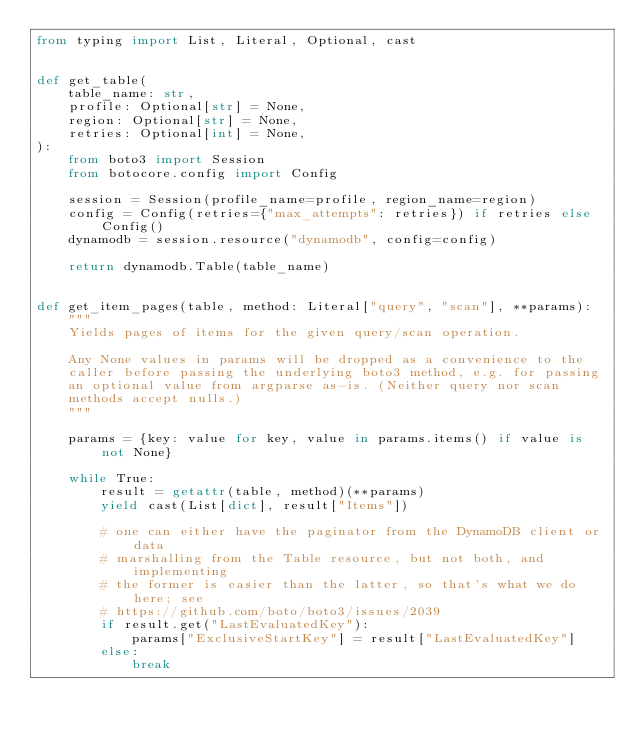<code> <loc_0><loc_0><loc_500><loc_500><_Python_>from typing import List, Literal, Optional, cast


def get_table(
    table_name: str,
    profile: Optional[str] = None,
    region: Optional[str] = None,
    retries: Optional[int] = None,
):
    from boto3 import Session
    from botocore.config import Config

    session = Session(profile_name=profile, region_name=region)
    config = Config(retries={"max_attempts": retries}) if retries else Config()
    dynamodb = session.resource("dynamodb", config=config)

    return dynamodb.Table(table_name)


def get_item_pages(table, method: Literal["query", "scan"], **params):
    """
    Yields pages of items for the given query/scan operation.

    Any None values in params will be dropped as a convenience to the
    caller before passing the underlying boto3 method, e.g. for passing
    an optional value from argparse as-is. (Neither query nor scan
    methods accept nulls.)
    """

    params = {key: value for key, value in params.items() if value is not None}

    while True:
        result = getattr(table, method)(**params)
        yield cast(List[dict], result["Items"])

        # one can either have the paginator from the DynamoDB client or data
        # marshalling from the Table resource, but not both, and implementing
        # the former is easier than the latter, so that's what we do here; see
        # https://github.com/boto/boto3/issues/2039
        if result.get("LastEvaluatedKey"):
            params["ExclusiveStartKey"] = result["LastEvaluatedKey"]
        else:
            break
</code> 